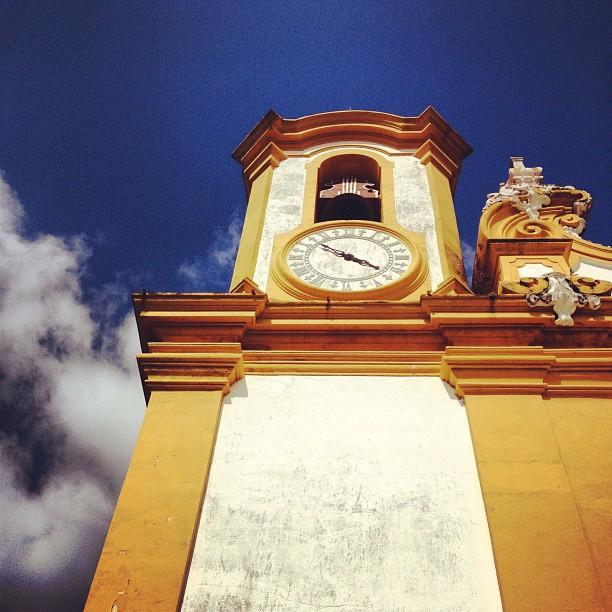Are there clouds?
Write a very short answer. Yes. Is the clock close to the ground?
Be succinct. No. What color is this building?
Give a very brief answer. Yellow. 